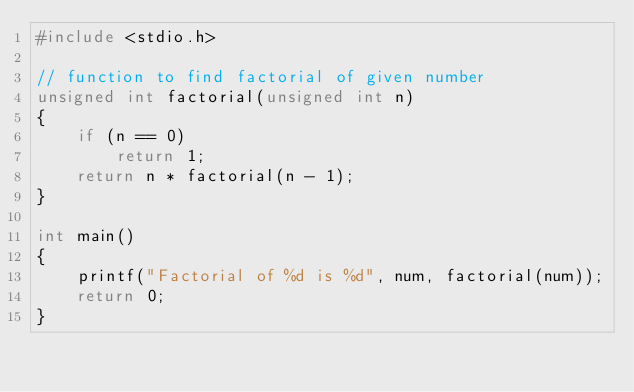<code> <loc_0><loc_0><loc_500><loc_500><_C_>#include <stdio.h> 
  
// function to find factorial of given number 
unsigned int factorial(unsigned int n) 
{ 
    if (n == 0) 
        return 1; 
    return n * factorial(n - 1); 
} 
  
int main() 
{ 
    printf("Factorial of %d is %d", num, factorial(num)); 
    return 0; 
} </code> 